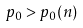Convert formula to latex. <formula><loc_0><loc_0><loc_500><loc_500>p _ { 0 } > p _ { 0 } ( n )</formula> 